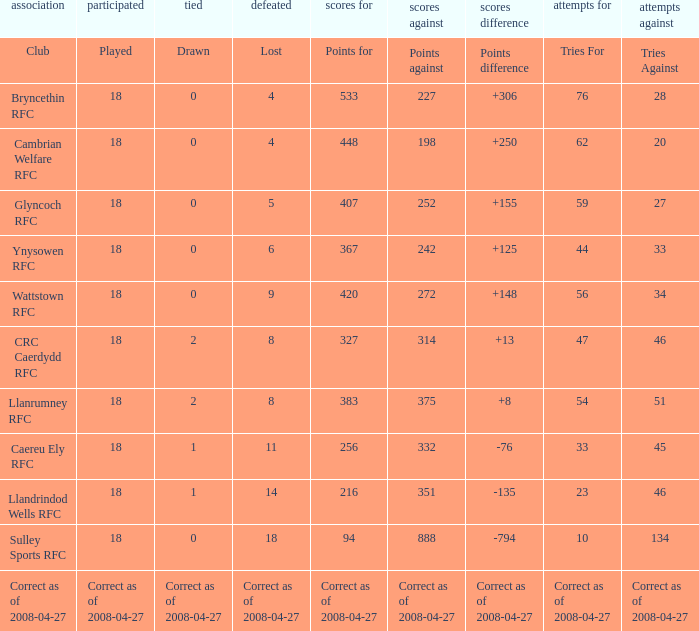What is the value for the item "Lost" when the value "Tries" is 47? 8.0. 